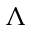Convert formula to latex. <formula><loc_0><loc_0><loc_500><loc_500>\Lambda</formula> 